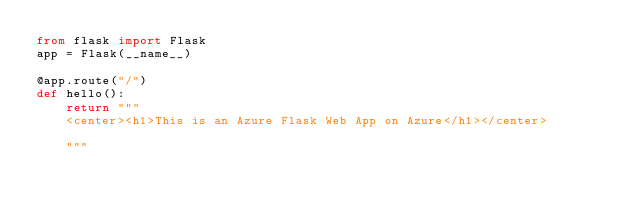Convert code to text. <code><loc_0><loc_0><loc_500><loc_500><_Python_>from flask import Flask
app = Flask(__name__)

@app.route("/")
def hello():
    return """
    <center><h1>This is an Azure Flask Web App on Azure</h1></center>
    
    """
</code> 